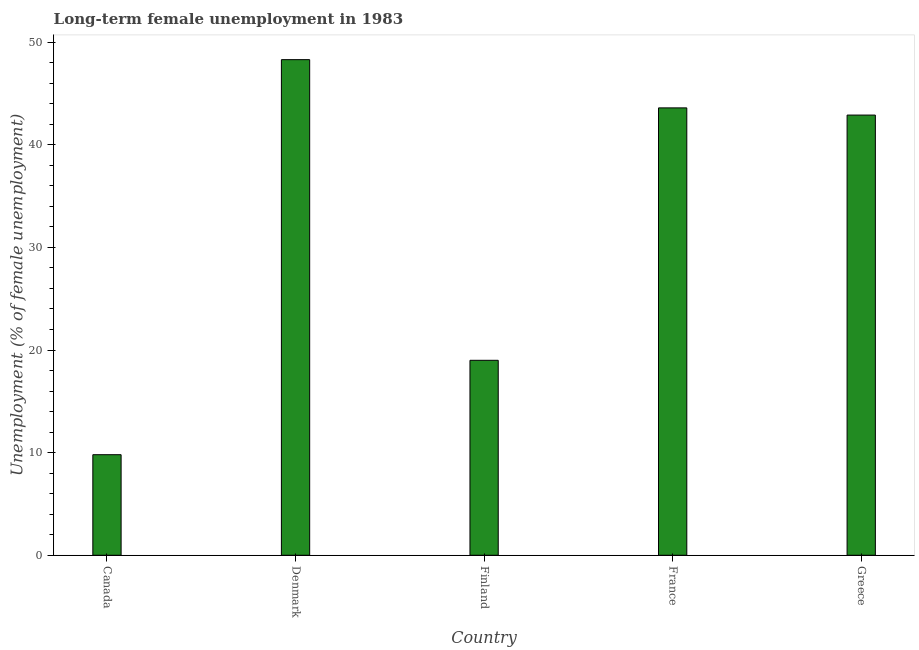Does the graph contain any zero values?
Keep it short and to the point. No. What is the title of the graph?
Offer a terse response. Long-term female unemployment in 1983. What is the label or title of the Y-axis?
Offer a very short reply. Unemployment (% of female unemployment). What is the long-term female unemployment in Canada?
Provide a short and direct response. 9.8. Across all countries, what is the maximum long-term female unemployment?
Keep it short and to the point. 48.3. Across all countries, what is the minimum long-term female unemployment?
Give a very brief answer. 9.8. What is the sum of the long-term female unemployment?
Your response must be concise. 163.6. What is the difference between the long-term female unemployment in France and Greece?
Provide a succinct answer. 0.7. What is the average long-term female unemployment per country?
Your answer should be compact. 32.72. What is the median long-term female unemployment?
Offer a very short reply. 42.9. What is the ratio of the long-term female unemployment in Finland to that in Greece?
Provide a short and direct response. 0.44. Is the long-term female unemployment in Denmark less than that in Greece?
Your response must be concise. No. Is the difference between the long-term female unemployment in Finland and Greece greater than the difference between any two countries?
Keep it short and to the point. No. What is the difference between the highest and the second highest long-term female unemployment?
Give a very brief answer. 4.7. What is the difference between the highest and the lowest long-term female unemployment?
Provide a short and direct response. 38.5. In how many countries, is the long-term female unemployment greater than the average long-term female unemployment taken over all countries?
Ensure brevity in your answer.  3. What is the Unemployment (% of female unemployment) in Canada?
Give a very brief answer. 9.8. What is the Unemployment (% of female unemployment) of Denmark?
Give a very brief answer. 48.3. What is the Unemployment (% of female unemployment) in Finland?
Keep it short and to the point. 19. What is the Unemployment (% of female unemployment) in France?
Keep it short and to the point. 43.6. What is the Unemployment (% of female unemployment) of Greece?
Offer a very short reply. 42.9. What is the difference between the Unemployment (% of female unemployment) in Canada and Denmark?
Provide a succinct answer. -38.5. What is the difference between the Unemployment (% of female unemployment) in Canada and France?
Your answer should be compact. -33.8. What is the difference between the Unemployment (% of female unemployment) in Canada and Greece?
Your response must be concise. -33.1. What is the difference between the Unemployment (% of female unemployment) in Denmark and Finland?
Your response must be concise. 29.3. What is the difference between the Unemployment (% of female unemployment) in Denmark and France?
Offer a terse response. 4.7. What is the difference between the Unemployment (% of female unemployment) in Denmark and Greece?
Make the answer very short. 5.4. What is the difference between the Unemployment (% of female unemployment) in Finland and France?
Your answer should be compact. -24.6. What is the difference between the Unemployment (% of female unemployment) in Finland and Greece?
Make the answer very short. -23.9. What is the ratio of the Unemployment (% of female unemployment) in Canada to that in Denmark?
Give a very brief answer. 0.2. What is the ratio of the Unemployment (% of female unemployment) in Canada to that in Finland?
Make the answer very short. 0.52. What is the ratio of the Unemployment (% of female unemployment) in Canada to that in France?
Give a very brief answer. 0.23. What is the ratio of the Unemployment (% of female unemployment) in Canada to that in Greece?
Your answer should be compact. 0.23. What is the ratio of the Unemployment (% of female unemployment) in Denmark to that in Finland?
Offer a terse response. 2.54. What is the ratio of the Unemployment (% of female unemployment) in Denmark to that in France?
Your answer should be compact. 1.11. What is the ratio of the Unemployment (% of female unemployment) in Denmark to that in Greece?
Offer a terse response. 1.13. What is the ratio of the Unemployment (% of female unemployment) in Finland to that in France?
Your answer should be compact. 0.44. What is the ratio of the Unemployment (% of female unemployment) in Finland to that in Greece?
Provide a short and direct response. 0.44. 